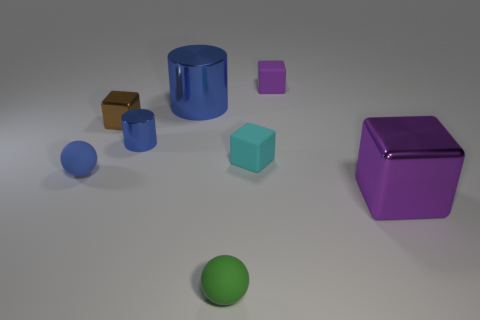What size is the metal block behind the matte sphere that is to the left of the small blue cylinder? The metal block positioned behind the matte sphere, which is to the left of the small blue cylinder, appears to be of medium size relative to the other objects in the scene. 